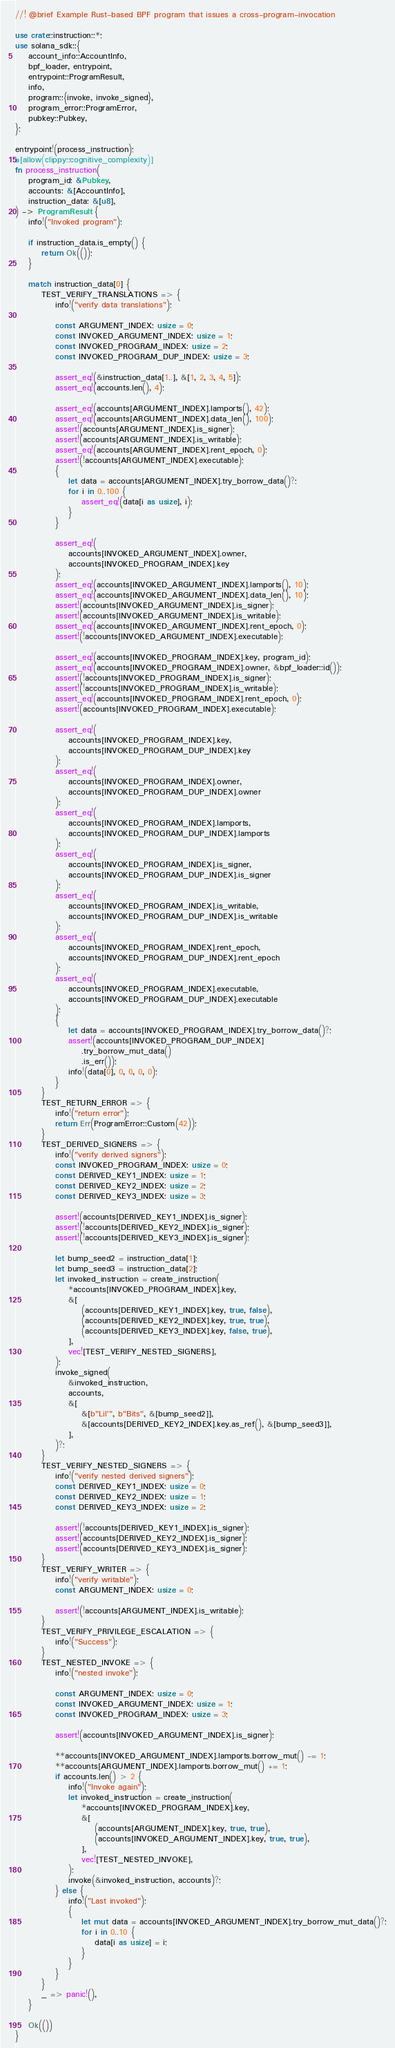Convert code to text. <code><loc_0><loc_0><loc_500><loc_500><_Rust_>//! @brief Example Rust-based BPF program that issues a cross-program-invocation

use crate::instruction::*;
use solana_sdk::{
    account_info::AccountInfo,
    bpf_loader, entrypoint,
    entrypoint::ProgramResult,
    info,
    program::{invoke, invoke_signed},
    program_error::ProgramError,
    pubkey::Pubkey,
};

entrypoint!(process_instruction);
#[allow(clippy::cognitive_complexity)]
fn process_instruction(
    program_id: &Pubkey,
    accounts: &[AccountInfo],
    instruction_data: &[u8],
) -> ProgramResult {
    info!("Invoked program");

    if instruction_data.is_empty() {
        return Ok(());
    }

    match instruction_data[0] {
        TEST_VERIFY_TRANSLATIONS => {
            info!("verify data translations");

            const ARGUMENT_INDEX: usize = 0;
            const INVOKED_ARGUMENT_INDEX: usize = 1;
            const INVOKED_PROGRAM_INDEX: usize = 2;
            const INVOKED_PROGRAM_DUP_INDEX: usize = 3;

            assert_eq!(&instruction_data[1..], &[1, 2, 3, 4, 5]);
            assert_eq!(accounts.len(), 4);

            assert_eq!(accounts[ARGUMENT_INDEX].lamports(), 42);
            assert_eq!(accounts[ARGUMENT_INDEX].data_len(), 100);
            assert!(accounts[ARGUMENT_INDEX].is_signer);
            assert!(accounts[ARGUMENT_INDEX].is_writable);
            assert_eq!(accounts[ARGUMENT_INDEX].rent_epoch, 0);
            assert!(!accounts[ARGUMENT_INDEX].executable);
            {
                let data = accounts[ARGUMENT_INDEX].try_borrow_data()?;
                for i in 0..100 {
                    assert_eq!(data[i as usize], i);
                }
            }

            assert_eq!(
                accounts[INVOKED_ARGUMENT_INDEX].owner,
                accounts[INVOKED_PROGRAM_INDEX].key
            );
            assert_eq!(accounts[INVOKED_ARGUMENT_INDEX].lamports(), 10);
            assert_eq!(accounts[INVOKED_ARGUMENT_INDEX].data_len(), 10);
            assert!(accounts[INVOKED_ARGUMENT_INDEX].is_signer);
            assert!(accounts[INVOKED_ARGUMENT_INDEX].is_writable);
            assert_eq!(accounts[INVOKED_ARGUMENT_INDEX].rent_epoch, 0);
            assert!(!accounts[INVOKED_ARGUMENT_INDEX].executable);

            assert_eq!(accounts[INVOKED_PROGRAM_INDEX].key, program_id);
            assert_eq!(accounts[INVOKED_PROGRAM_INDEX].owner, &bpf_loader::id());
            assert!(!accounts[INVOKED_PROGRAM_INDEX].is_signer);
            assert!(!accounts[INVOKED_PROGRAM_INDEX].is_writable);
            assert_eq!(accounts[INVOKED_PROGRAM_INDEX].rent_epoch, 0);
            assert!(accounts[INVOKED_PROGRAM_INDEX].executable);

            assert_eq!(
                accounts[INVOKED_PROGRAM_INDEX].key,
                accounts[INVOKED_PROGRAM_DUP_INDEX].key
            );
            assert_eq!(
                accounts[INVOKED_PROGRAM_INDEX].owner,
                accounts[INVOKED_PROGRAM_DUP_INDEX].owner
            );
            assert_eq!(
                accounts[INVOKED_PROGRAM_INDEX].lamports,
                accounts[INVOKED_PROGRAM_DUP_INDEX].lamports
            );
            assert_eq!(
                accounts[INVOKED_PROGRAM_INDEX].is_signer,
                accounts[INVOKED_PROGRAM_DUP_INDEX].is_signer
            );
            assert_eq!(
                accounts[INVOKED_PROGRAM_INDEX].is_writable,
                accounts[INVOKED_PROGRAM_DUP_INDEX].is_writable
            );
            assert_eq!(
                accounts[INVOKED_PROGRAM_INDEX].rent_epoch,
                accounts[INVOKED_PROGRAM_DUP_INDEX].rent_epoch
            );
            assert_eq!(
                accounts[INVOKED_PROGRAM_INDEX].executable,
                accounts[INVOKED_PROGRAM_DUP_INDEX].executable
            );
            {
                let data = accounts[INVOKED_PROGRAM_INDEX].try_borrow_data()?;
                assert!(accounts[INVOKED_PROGRAM_DUP_INDEX]
                    .try_borrow_mut_data()
                    .is_err());
                info!(data[0], 0, 0, 0, 0);
            }
        }
        TEST_RETURN_ERROR => {
            info!("return error");
            return Err(ProgramError::Custom(42));
        }
        TEST_DERIVED_SIGNERS => {
            info!("verify derived signers");
            const INVOKED_PROGRAM_INDEX: usize = 0;
            const DERIVED_KEY1_INDEX: usize = 1;
            const DERIVED_KEY2_INDEX: usize = 2;
            const DERIVED_KEY3_INDEX: usize = 3;

            assert!(accounts[DERIVED_KEY1_INDEX].is_signer);
            assert!(!accounts[DERIVED_KEY2_INDEX].is_signer);
            assert!(!accounts[DERIVED_KEY3_INDEX].is_signer);

            let bump_seed2 = instruction_data[1];
            let bump_seed3 = instruction_data[2];
            let invoked_instruction = create_instruction(
                *accounts[INVOKED_PROGRAM_INDEX].key,
                &[
                    (accounts[DERIVED_KEY1_INDEX].key, true, false),
                    (accounts[DERIVED_KEY2_INDEX].key, true, true),
                    (accounts[DERIVED_KEY3_INDEX].key, false, true),
                ],
                vec![TEST_VERIFY_NESTED_SIGNERS],
            );
            invoke_signed(
                &invoked_instruction,
                accounts,
                &[
                    &[b"Lil'", b"Bits", &[bump_seed2]],
                    &[accounts[DERIVED_KEY2_INDEX].key.as_ref(), &[bump_seed3]],
                ],
            )?;
        }
        TEST_VERIFY_NESTED_SIGNERS => {
            info!("verify nested derived signers");
            const DERIVED_KEY1_INDEX: usize = 0;
            const DERIVED_KEY2_INDEX: usize = 1;
            const DERIVED_KEY3_INDEX: usize = 2;

            assert!(!accounts[DERIVED_KEY1_INDEX].is_signer);
            assert!(accounts[DERIVED_KEY2_INDEX].is_signer);
            assert!(accounts[DERIVED_KEY3_INDEX].is_signer);
        }
        TEST_VERIFY_WRITER => {
            info!("verify writable");
            const ARGUMENT_INDEX: usize = 0;

            assert!(!accounts[ARGUMENT_INDEX].is_writable);
        }
        TEST_VERIFY_PRIVILEGE_ESCALATION => {
            info!("Success");
        }
        TEST_NESTED_INVOKE => {
            info!("nested invoke");

            const ARGUMENT_INDEX: usize = 0;
            const INVOKED_ARGUMENT_INDEX: usize = 1;
            const INVOKED_PROGRAM_INDEX: usize = 3;

            assert!(accounts[INVOKED_ARGUMENT_INDEX].is_signer);

            **accounts[INVOKED_ARGUMENT_INDEX].lamports.borrow_mut() -= 1;
            **accounts[ARGUMENT_INDEX].lamports.borrow_mut() += 1;
            if accounts.len() > 2 {
                info!("Invoke again");
                let invoked_instruction = create_instruction(
                    *accounts[INVOKED_PROGRAM_INDEX].key,
                    &[
                        (accounts[ARGUMENT_INDEX].key, true, true),
                        (accounts[INVOKED_ARGUMENT_INDEX].key, true, true),
                    ],
                    vec![TEST_NESTED_INVOKE],
                );
                invoke(&invoked_instruction, accounts)?;
            } else {
                info!("Last invoked");
                {
                    let mut data = accounts[INVOKED_ARGUMENT_INDEX].try_borrow_mut_data()?;
                    for i in 0..10 {
                        data[i as usize] = i;
                    }
                }
            }
        }
        _ => panic!(),
    }

    Ok(())
}
</code> 